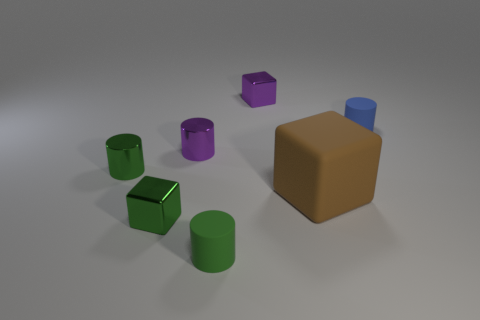What number of other objects are the same size as the green metallic cylinder?
Provide a succinct answer. 5. What is the color of the other rubber thing that is the same shape as the blue object?
Offer a very short reply. Green. The brown cube has what size?
Make the answer very short. Large. What color is the small rubber cylinder behind the tiny rubber cylinder that is in front of the brown matte cube?
Offer a terse response. Blue. How many small green objects are behind the green rubber thing and in front of the brown matte thing?
Your answer should be compact. 1. Are there more big blocks than rubber cylinders?
Provide a short and direct response. No. What is the material of the purple block?
Your answer should be compact. Metal. How many green things are on the right side of the tiny metallic block that is behind the large rubber block?
Your answer should be compact. 0. Is the color of the big block the same as the small rubber thing that is behind the green matte cylinder?
Keep it short and to the point. No. What is the color of the other cube that is the same size as the purple metal cube?
Provide a succinct answer. Green. 